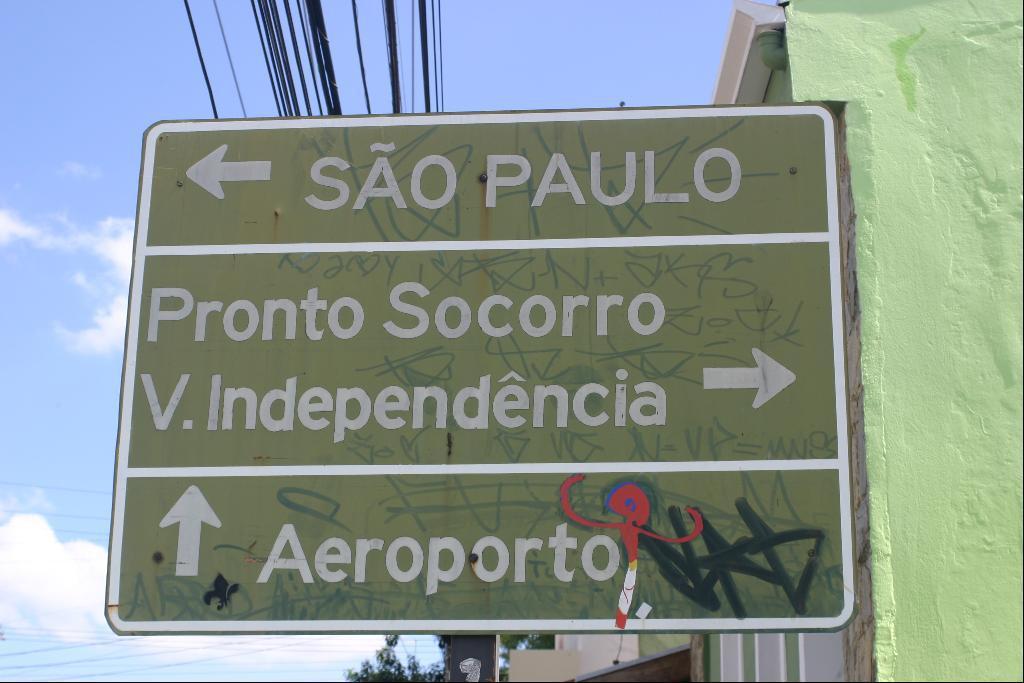Describe this image in one or two sentences. In this image there is a sign board ,on that board there is some text on above that there are wires and cloudy sky, on the right there is wall. 